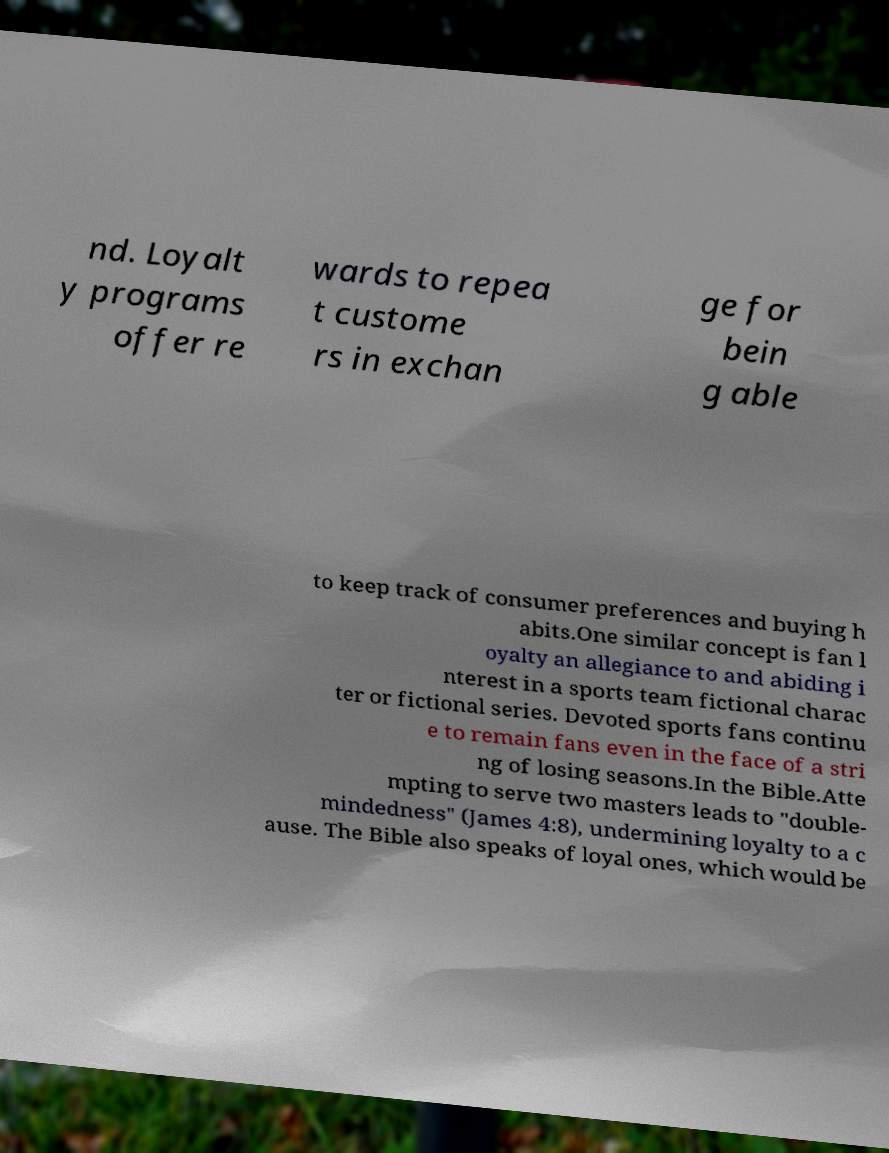I need the written content from this picture converted into text. Can you do that? nd. Loyalt y programs offer re wards to repea t custome rs in exchan ge for bein g able to keep track of consumer preferences and buying h abits.One similar concept is fan l oyalty an allegiance to and abiding i nterest in a sports team fictional charac ter or fictional series. Devoted sports fans continu e to remain fans even in the face of a stri ng of losing seasons.In the Bible.Atte mpting to serve two masters leads to "double- mindedness" (James 4:8), undermining loyalty to a c ause. The Bible also speaks of loyal ones, which would be 